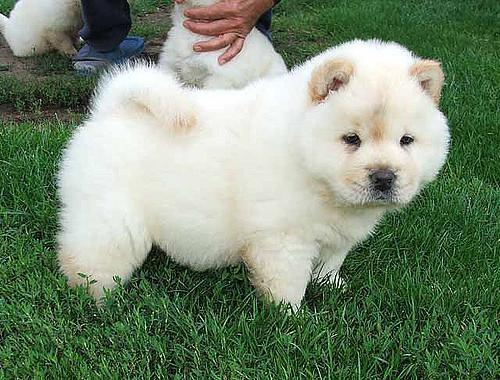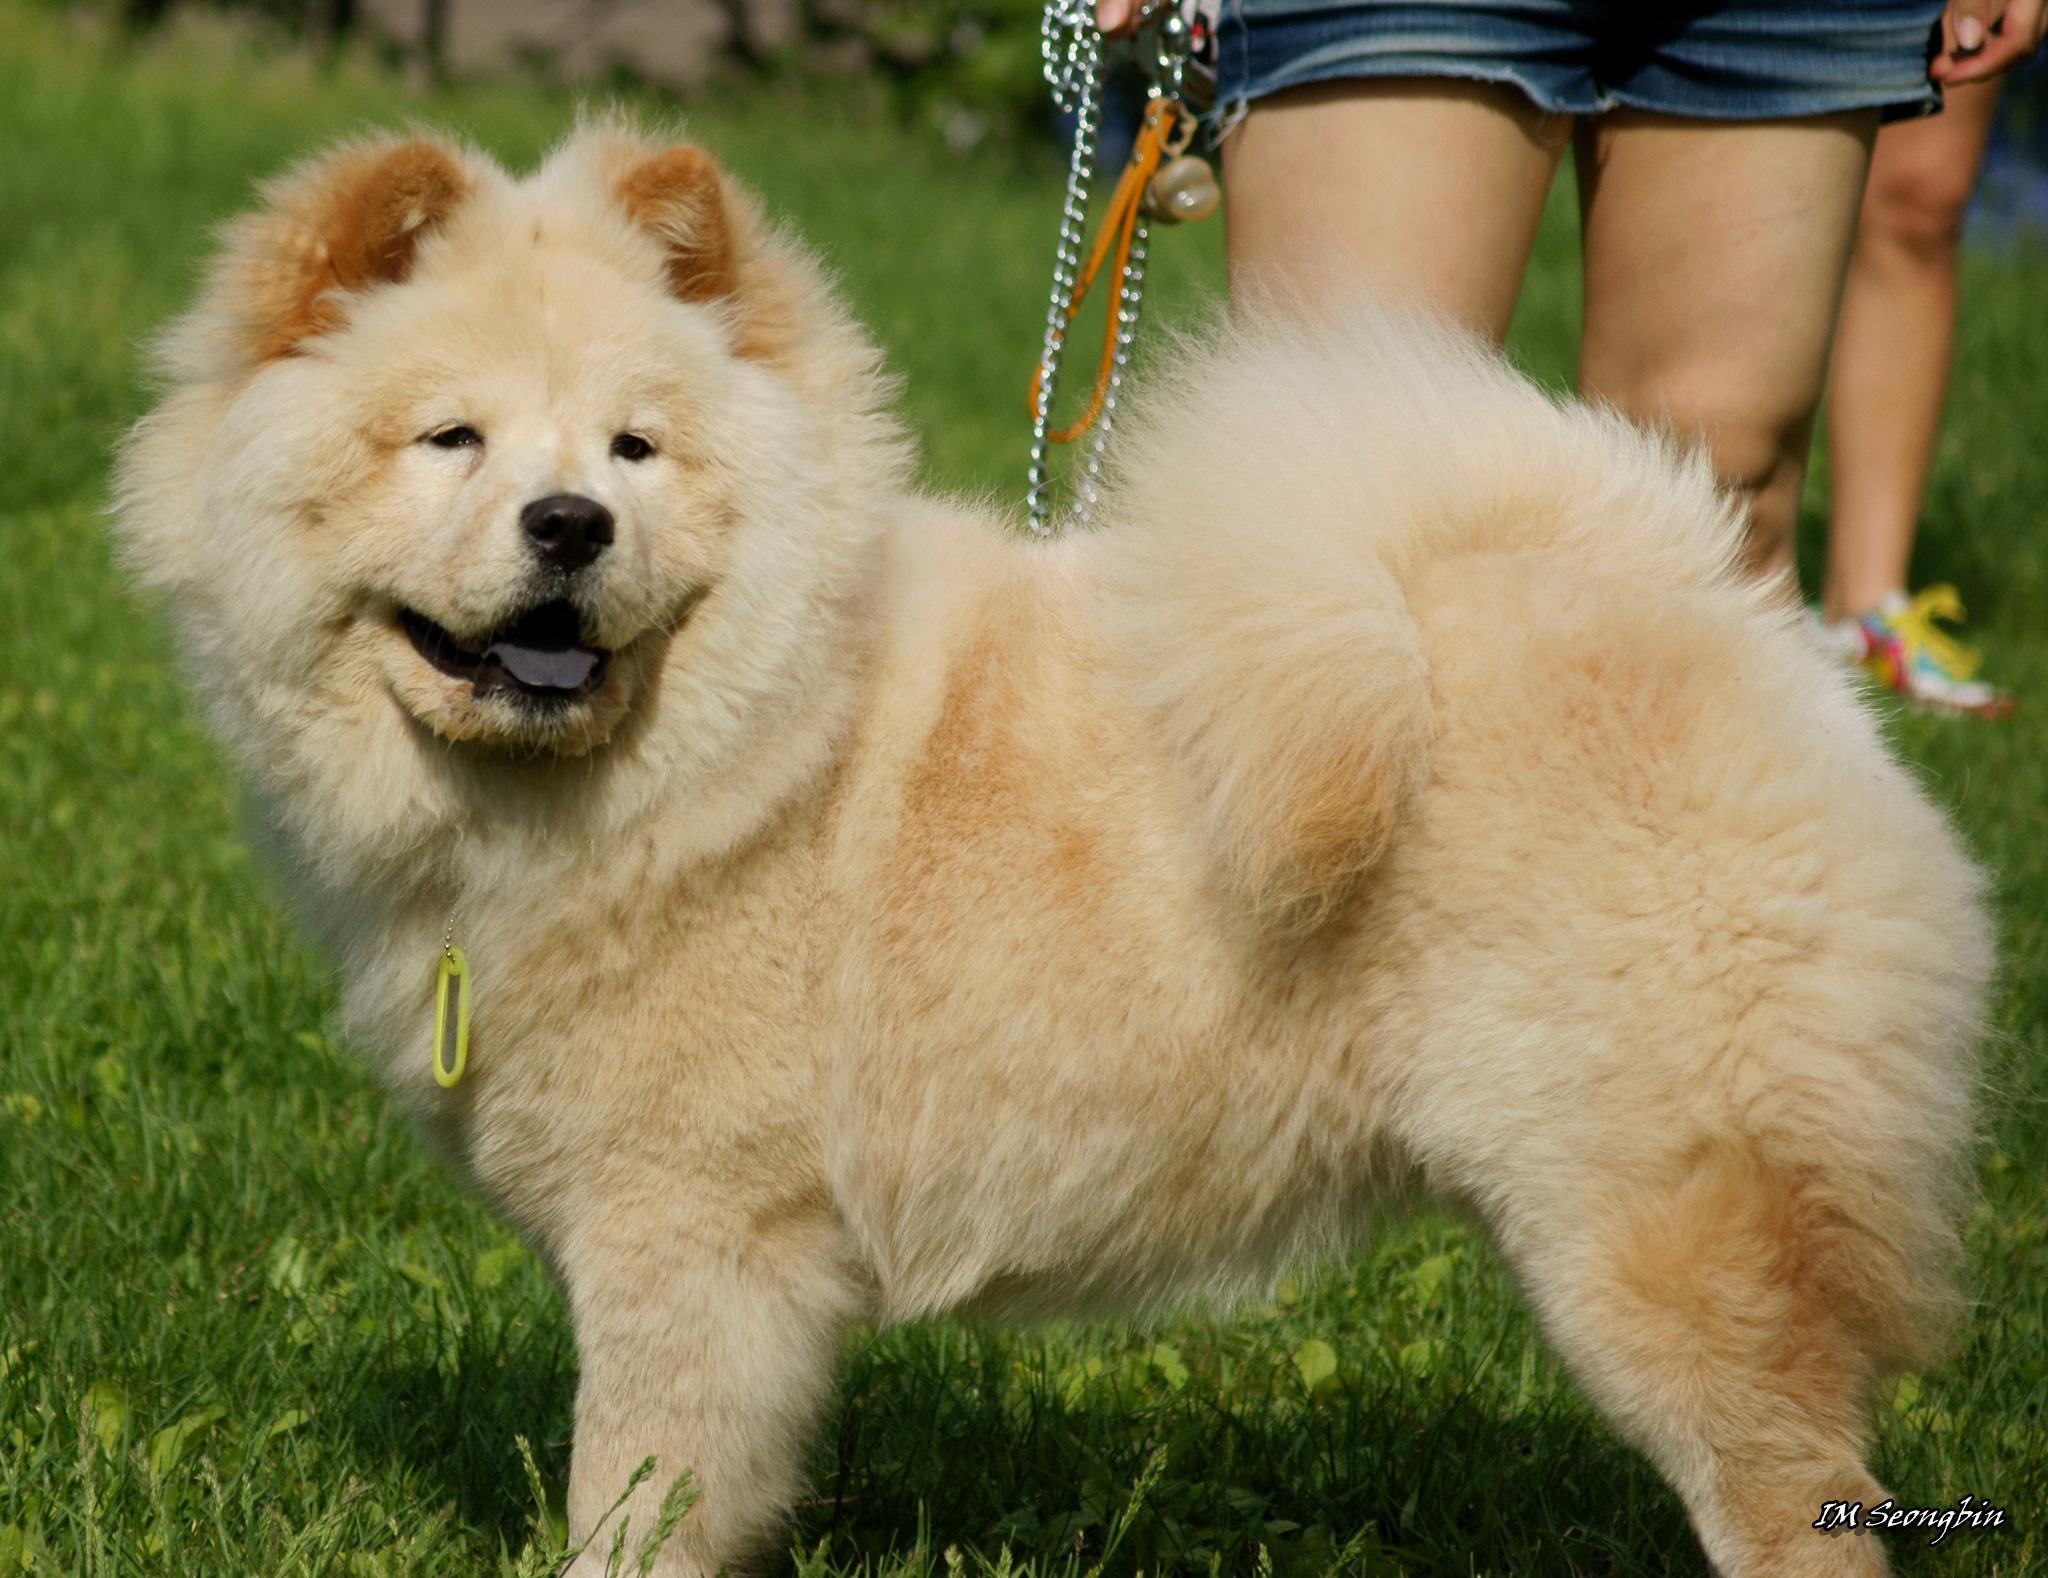The first image is the image on the left, the second image is the image on the right. For the images shown, is this caption "There are two dogs, and neither of them has anything in their mouth." true? Answer yes or no. Yes. The first image is the image on the left, the second image is the image on the right. Given the left and right images, does the statement "An image shows one cream-colored chow in a non-standing pose on the grass." hold true? Answer yes or no. No. 